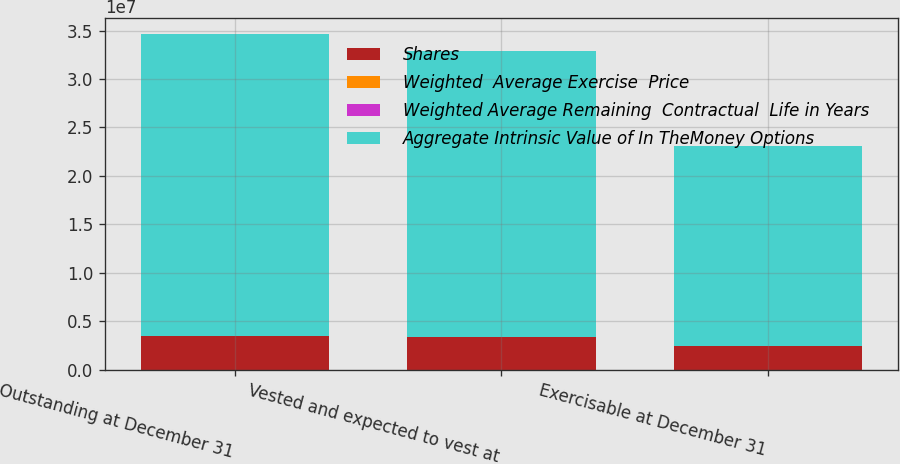Convert chart to OTSL. <chart><loc_0><loc_0><loc_500><loc_500><stacked_bar_chart><ecel><fcel>Outstanding at December 31<fcel>Vested and expected to vest at<fcel>Exercisable at December 31<nl><fcel>Shares<fcel>3.50072e+06<fcel>3.37082e+06<fcel>2.46165e+06<nl><fcel>Weighted  Average Exercise  Price<fcel>35.31<fcel>35.44<fcel>35.31<nl><fcel>Weighted Average Remaining  Contractual  Life in Years<fcel>3.21<fcel>3.11<fcel>2.21<nl><fcel>Aggregate Intrinsic Value of In TheMoney Options<fcel>3.1121e+07<fcel>2.95158e+07<fcel>2.06667e+07<nl></chart> 